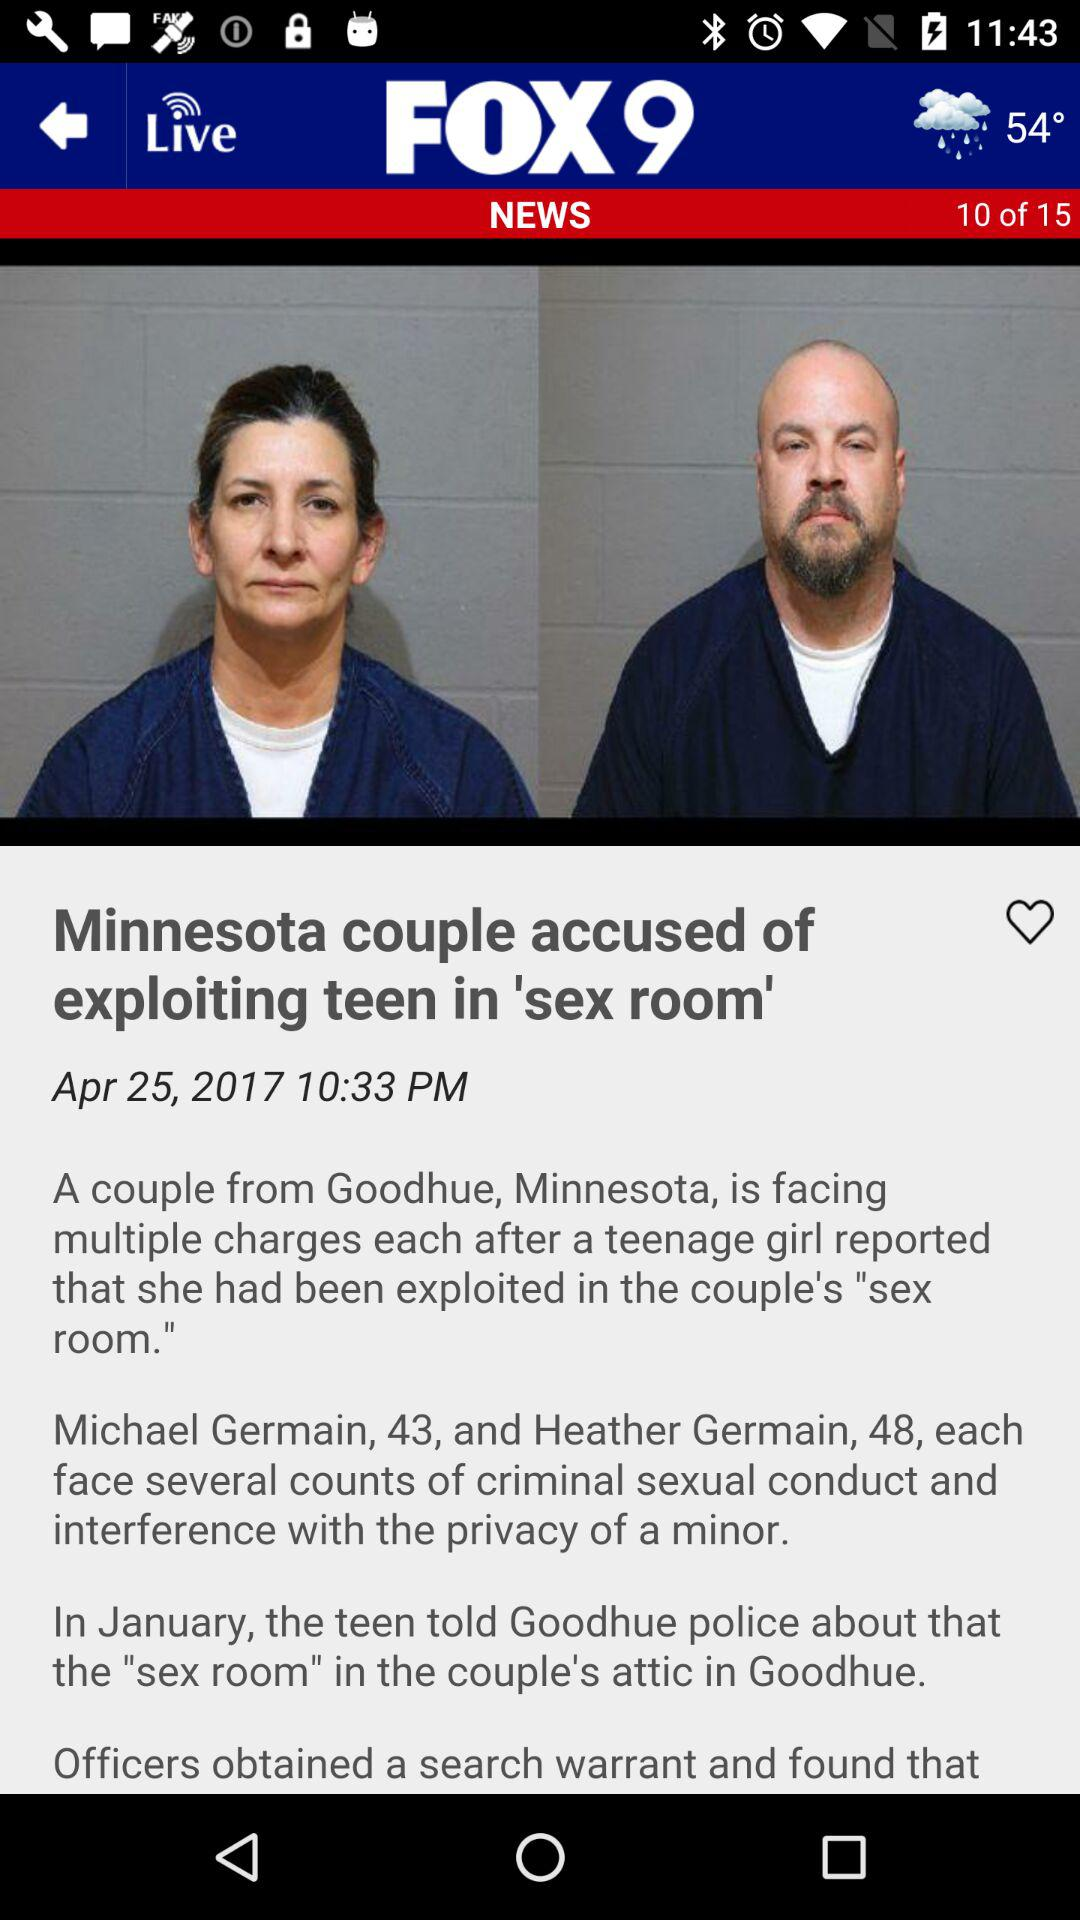Please describe the contents of the news article shown in the image. The news article discusses a case involving a couple from Goodhue, Minnesota, accused of criminal sexual conduct and interfering with the privacy of a minor. It details allegations of misuse of a 'sex room' in their attic. What are the charges mentioned in the article against the individuals? The couple, identified only as Michael and Heather, are charged with several counts of criminal sexual conduct and interference with the privacy of a minor. 